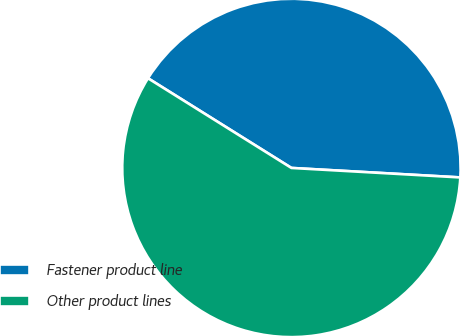Convert chart. <chart><loc_0><loc_0><loc_500><loc_500><pie_chart><fcel>Fastener product line<fcel>Other product lines<nl><fcel>42.0%<fcel>58.0%<nl></chart> 